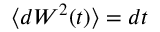Convert formula to latex. <formula><loc_0><loc_0><loc_500><loc_500>\langle d W ^ { 2 } ( t ) \rangle = d t</formula> 